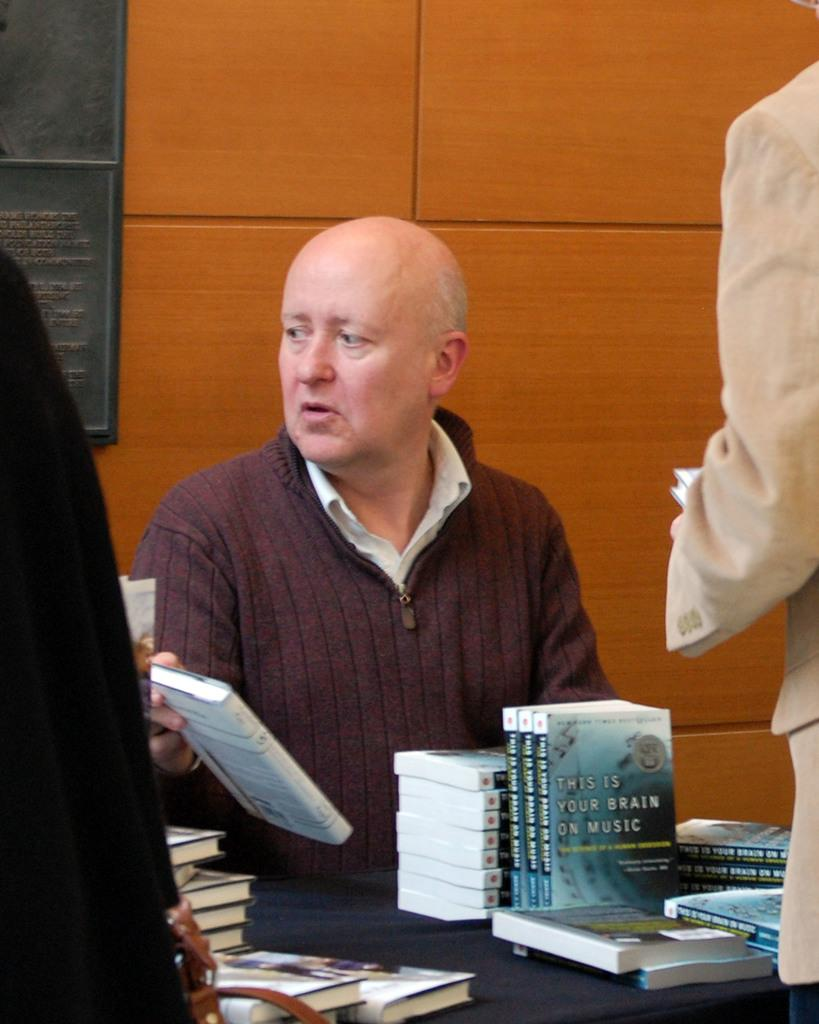<image>
Relay a brief, clear account of the picture shown. A man with a stack of books titled This is your brain on music. 